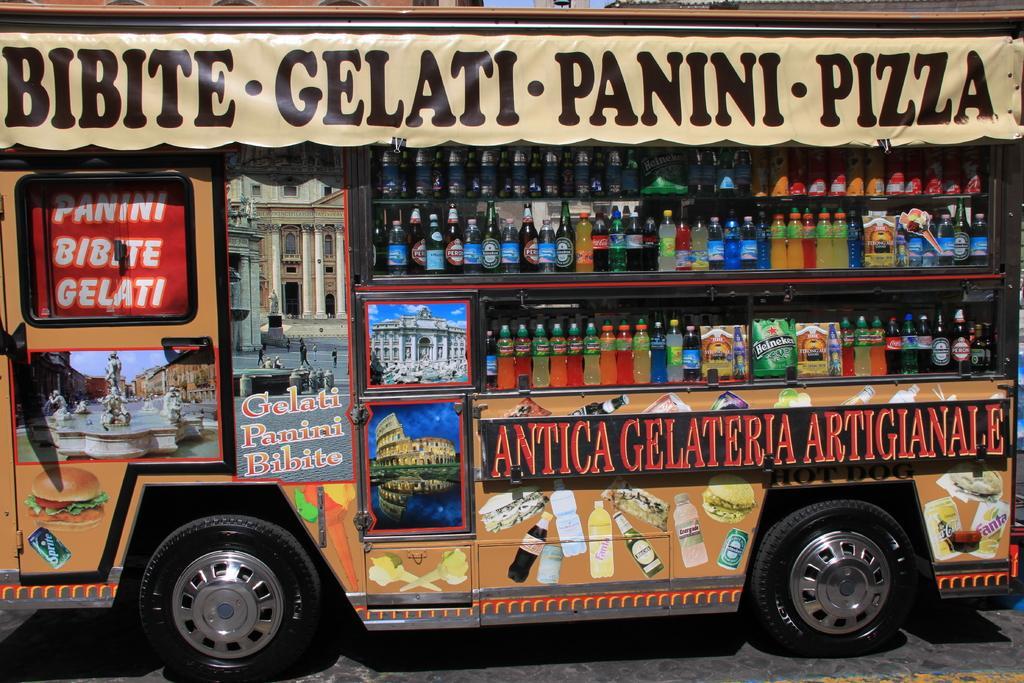Describe this image in one or two sentences. This image is taken orders. At the bottom of the image there is a road. In the middle of the image there is a van with a few paintings and there is a text on the van. There is a banner with a text on it. There are many bottles on the shelves. 